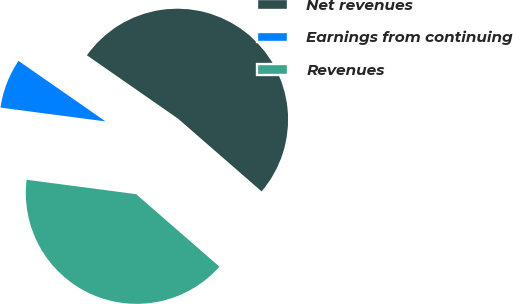Convert chart. <chart><loc_0><loc_0><loc_500><loc_500><pie_chart><fcel>Net revenues<fcel>Earnings from continuing<fcel>Revenues<nl><fcel>51.73%<fcel>7.59%<fcel>40.68%<nl></chart> 